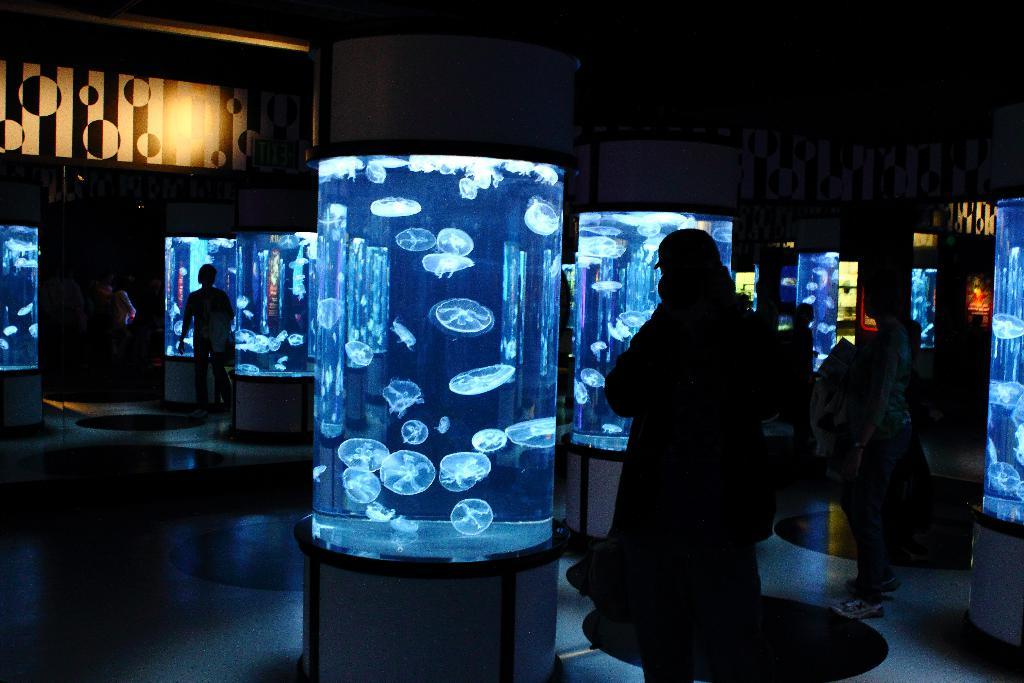Who or what can be seen in the image? There are people in the image. What type of objects are present in the image? There are aquariums in the image, and jellyfish are present in the aquariums. Can you describe the left side of the image? There is a board on the left side of the image. What is visible in the center of the background? There are posters in the center of the background. What type of machine is being used by the people in the image? There is no machine visible in the image; the people are interacting with aquariums and posters. Can you see any bats flying around in the image? There are no bats present in the image. 